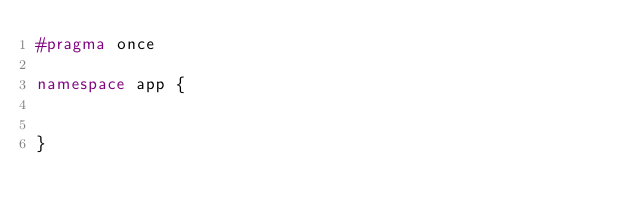<code> <loc_0><loc_0><loc_500><loc_500><_C++_>#pragma once

namespace app {


}
</code> 